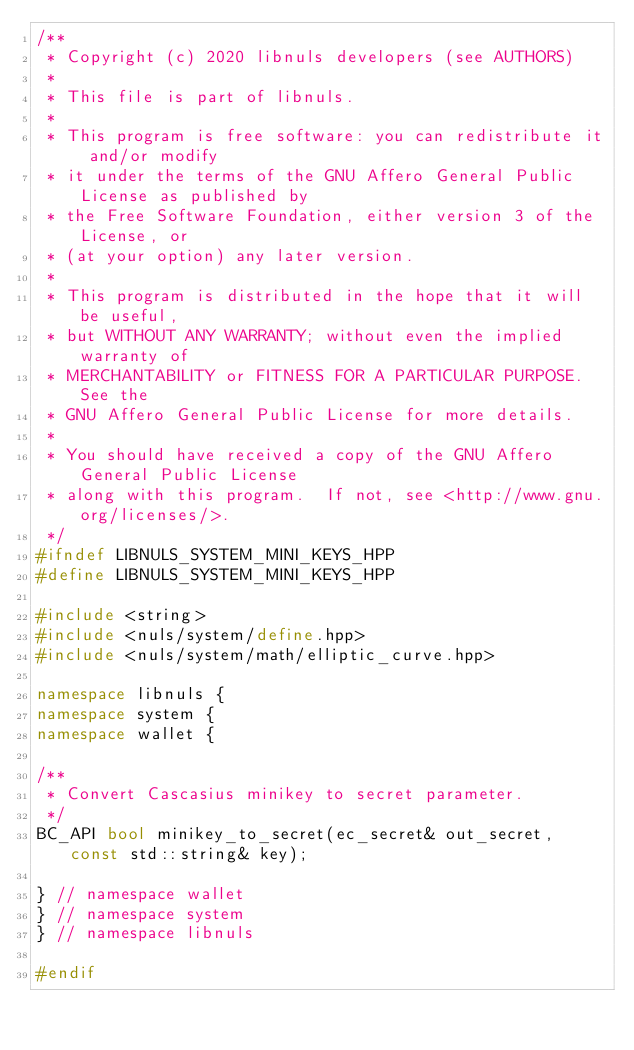<code> <loc_0><loc_0><loc_500><loc_500><_C++_>/**
 * Copyright (c) 2020 libnuls developers (see AUTHORS)
 *
 * This file is part of libnuls.
 *
 * This program is free software: you can redistribute it and/or modify
 * it under the terms of the GNU Affero General Public License as published by
 * the Free Software Foundation, either version 3 of the License, or
 * (at your option) any later version.
 *
 * This program is distributed in the hope that it will be useful,
 * but WITHOUT ANY WARRANTY; without even the implied warranty of
 * MERCHANTABILITY or FITNESS FOR A PARTICULAR PURPOSE.  See the
 * GNU Affero General Public License for more details.
 *
 * You should have received a copy of the GNU Affero General Public License
 * along with this program.  If not, see <http://www.gnu.org/licenses/>.
 */
#ifndef LIBNULS_SYSTEM_MINI_KEYS_HPP
#define LIBNULS_SYSTEM_MINI_KEYS_HPP

#include <string>
#include <nuls/system/define.hpp>
#include <nuls/system/math/elliptic_curve.hpp>

namespace libnuls {
namespace system {
namespace wallet {

/**
 * Convert Cascasius minikey to secret parameter.
 */
BC_API bool minikey_to_secret(ec_secret& out_secret, const std::string& key);

} // namespace wallet
} // namespace system
} // namespace libnuls

#endif
</code> 